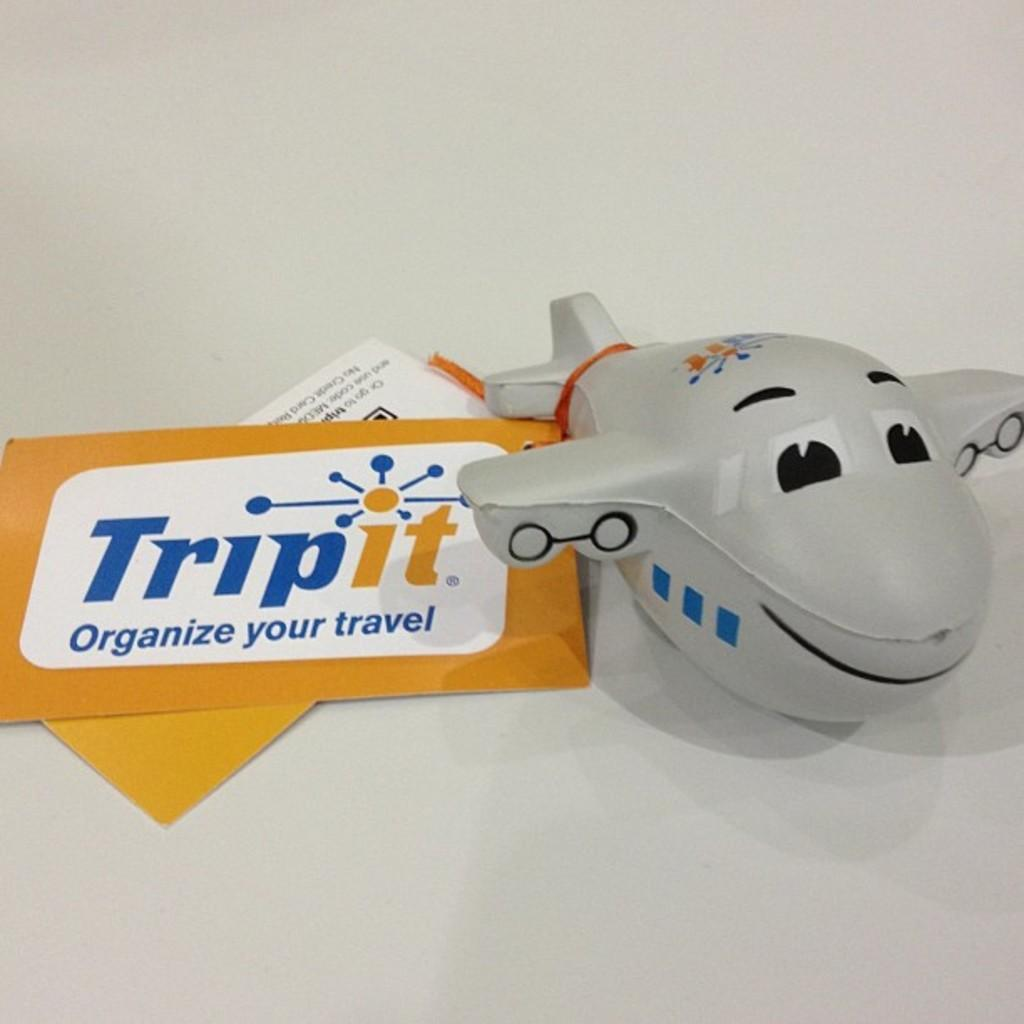Provide a one-sentence caption for the provided image. A grey plane toy and a Trip it brand label beside it.beside. 